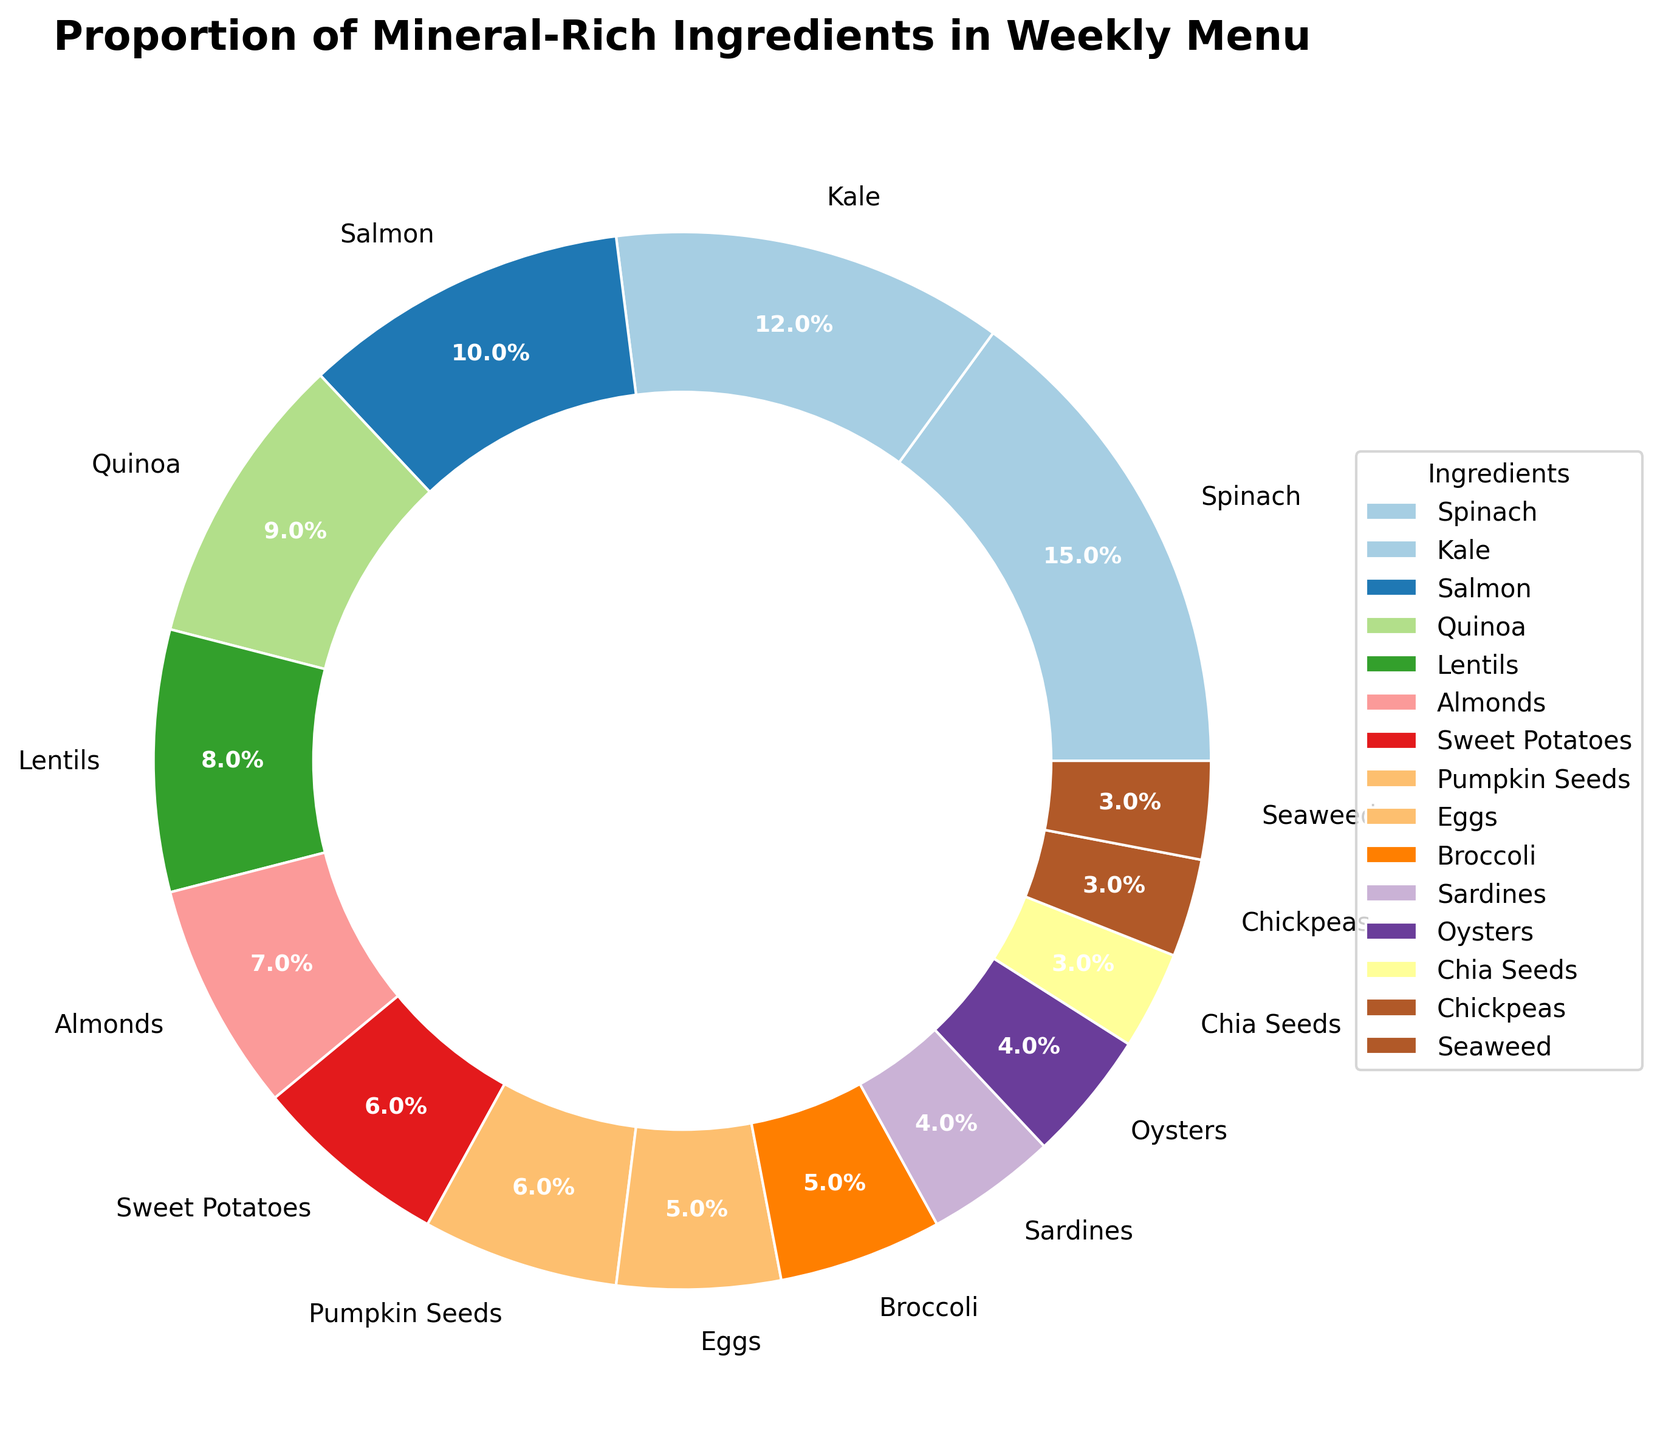Which ingredient has the highest proportion in the weekly menu? From the pie chart, the ingredient that takes up the largest section is Spinach.
Answer: Spinach Which two ingredients have the lowest proportions in the weekly menu? By observing the pie chart, the smallest slices correspond to Chia Seeds, Chickpeas, and Seaweed, each with a slice approximately 3%.
Answer: Chia Seeds, Chickpeas, Seaweed What is the combined percentage of Kale and Quinoa? From the pie chart, Kale accounts for 12% and Quinoa for 9%. Adding these percentages together gives 12% + 9% = 21%.
Answer: 21% Is the proportion of Sweet Potatoes greater or smaller than that of Lentils? Sweet Potatoes account for 6%, while Lentils account for 8%. 6% is smaller than 8%.
Answer: Smaller What is the average percentage of Almonds, Sweet Potatoes, and Pumpkin Seeds? The percentages are Almonds 7%, Sweet Potatoes 6%, and Pumpkin Seeds 6%. To find the average: (7% + 6% + 6%) / 3 = 19% / 3 = 6.33%.
Answer: 6.33% Which ingredient has a higher percentage, Salmon or Sardines? From the pie chart, Salmon accounts for 10%, while Sardines account for 4%. Hence, Salmon has a higher percentage.
Answer: Salmon What is the difference in percentage between the highest and lowest contributing ingredients? The highest contributing ingredient is Spinach at 15%, and the lowest are Chia Seeds, Chickpeas, and Seaweed at 3%. The difference is 15% - 3% = 12%.
Answer: 12% If you sum up the percentages of all the leafy greens (Spinach, Kale, and Broccoli), what do you get? Spinach accounts for 15%, Kale for 12%, and Broccoli for 5%. The sum is 15% + 12% + 5% = 32%.
Answer: 32% What is the combined proportion of all seafood ingredients (Salmon, Sardines, and Oysters)? Salmon is 10%, Sardines are 4%, and Oysters are 4%. Summing these gives 10% + 4% + 4% = 18%.
Answer: 18% Which ingredient and by how much has the closest proportion to Eggs? Eggs have a proportion of 5%. Both Broccoli, also with 5%, and Almonds with 7%, are close, but Broccoli is exactly 5%.
Answer: Broccoli, 0% 